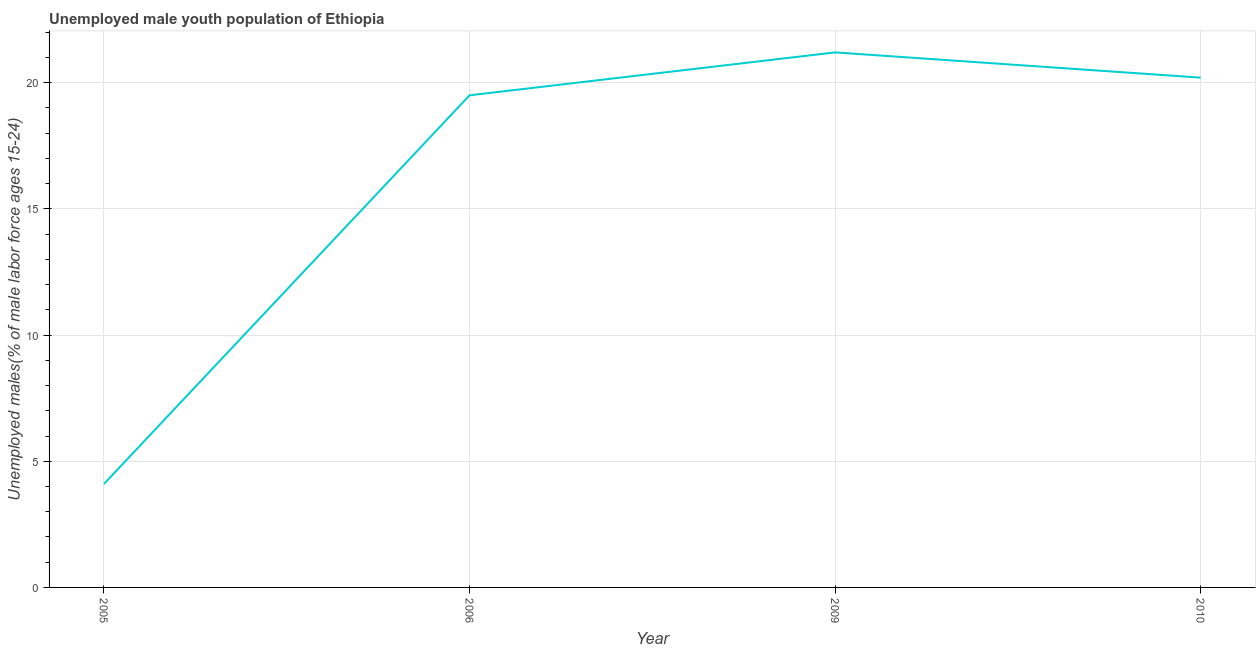What is the unemployed male youth in 2005?
Provide a short and direct response. 4.1. Across all years, what is the maximum unemployed male youth?
Give a very brief answer. 21.2. Across all years, what is the minimum unemployed male youth?
Offer a very short reply. 4.1. In which year was the unemployed male youth maximum?
Your answer should be compact. 2009. What is the sum of the unemployed male youth?
Provide a succinct answer. 65. What is the difference between the unemployed male youth in 2005 and 2010?
Your response must be concise. -16.1. What is the average unemployed male youth per year?
Ensure brevity in your answer.  16.25. What is the median unemployed male youth?
Keep it short and to the point. 19.85. In how many years, is the unemployed male youth greater than 20 %?
Provide a short and direct response. 2. Do a majority of the years between 2009 and 2006 (inclusive) have unemployed male youth greater than 18 %?
Keep it short and to the point. No. What is the ratio of the unemployed male youth in 2009 to that in 2010?
Give a very brief answer. 1.05. Is the unemployed male youth in 2009 less than that in 2010?
Your answer should be compact. No. Is the sum of the unemployed male youth in 2009 and 2010 greater than the maximum unemployed male youth across all years?
Ensure brevity in your answer.  Yes. What is the difference between the highest and the lowest unemployed male youth?
Your answer should be very brief. 17.1. In how many years, is the unemployed male youth greater than the average unemployed male youth taken over all years?
Provide a short and direct response. 3. Does the unemployed male youth monotonically increase over the years?
Your response must be concise. No. How many years are there in the graph?
Make the answer very short. 4. Are the values on the major ticks of Y-axis written in scientific E-notation?
Provide a succinct answer. No. Does the graph contain any zero values?
Offer a very short reply. No. Does the graph contain grids?
Ensure brevity in your answer.  Yes. What is the title of the graph?
Your answer should be compact. Unemployed male youth population of Ethiopia. What is the label or title of the Y-axis?
Offer a very short reply. Unemployed males(% of male labor force ages 15-24). What is the Unemployed males(% of male labor force ages 15-24) in 2005?
Offer a terse response. 4.1. What is the Unemployed males(% of male labor force ages 15-24) in 2009?
Offer a very short reply. 21.2. What is the Unemployed males(% of male labor force ages 15-24) of 2010?
Offer a terse response. 20.2. What is the difference between the Unemployed males(% of male labor force ages 15-24) in 2005 and 2006?
Provide a short and direct response. -15.4. What is the difference between the Unemployed males(% of male labor force ages 15-24) in 2005 and 2009?
Offer a very short reply. -17.1. What is the difference between the Unemployed males(% of male labor force ages 15-24) in 2005 and 2010?
Your answer should be compact. -16.1. What is the ratio of the Unemployed males(% of male labor force ages 15-24) in 2005 to that in 2006?
Your answer should be very brief. 0.21. What is the ratio of the Unemployed males(% of male labor force ages 15-24) in 2005 to that in 2009?
Provide a succinct answer. 0.19. What is the ratio of the Unemployed males(% of male labor force ages 15-24) in 2005 to that in 2010?
Ensure brevity in your answer.  0.2. What is the ratio of the Unemployed males(% of male labor force ages 15-24) in 2006 to that in 2009?
Keep it short and to the point. 0.92. What is the ratio of the Unemployed males(% of male labor force ages 15-24) in 2006 to that in 2010?
Your answer should be very brief. 0.96. What is the ratio of the Unemployed males(% of male labor force ages 15-24) in 2009 to that in 2010?
Make the answer very short. 1.05. 